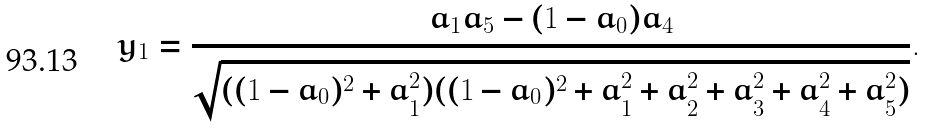Convert formula to latex. <formula><loc_0><loc_0><loc_500><loc_500>y _ { 1 } = \frac { a _ { 1 } a _ { 5 } - ( 1 - a _ { 0 } ) a _ { 4 } } { \sqrt { ( ( 1 - a _ { 0 } ) ^ { 2 } + a _ { 1 } ^ { 2 } ) ( ( 1 - a _ { 0 } ) ^ { 2 } + a _ { 1 } ^ { 2 } + a _ { 2 } ^ { 2 } + a _ { 3 } ^ { 2 } + a _ { 4 } ^ { 2 } + a _ { 5 } ^ { 2 } ) } } .</formula> 